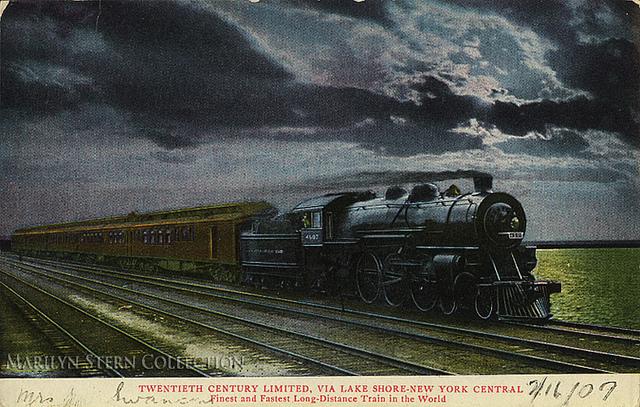What collection is this image from?
Short answer required. Marilyn stern. Which direction is the train traveling?
Give a very brief answer. North. What time of day is the scene taking place?
Short answer required. Daytime. 